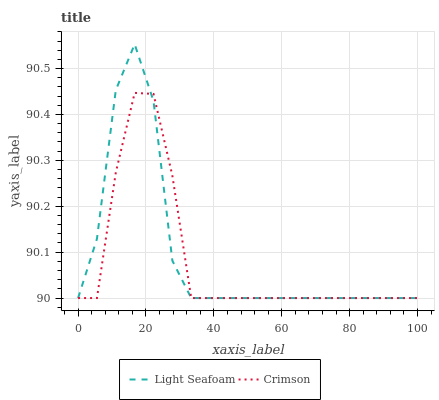Does Crimson have the minimum area under the curve?
Answer yes or no. Yes. Does Light Seafoam have the maximum area under the curve?
Answer yes or no. Yes. Does Light Seafoam have the minimum area under the curve?
Answer yes or no. No. Is Crimson the smoothest?
Answer yes or no. Yes. Is Light Seafoam the roughest?
Answer yes or no. Yes. Is Light Seafoam the smoothest?
Answer yes or no. No. Does Crimson have the lowest value?
Answer yes or no. Yes. Does Light Seafoam have the highest value?
Answer yes or no. Yes. Does Light Seafoam intersect Crimson?
Answer yes or no. Yes. Is Light Seafoam less than Crimson?
Answer yes or no. No. Is Light Seafoam greater than Crimson?
Answer yes or no. No. 